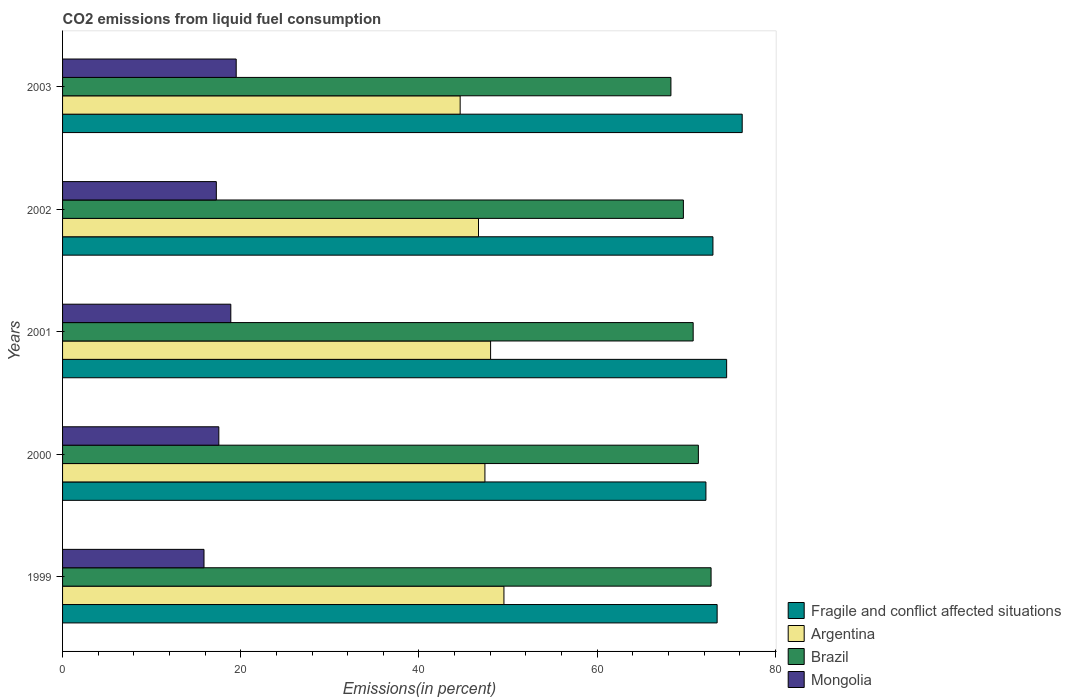How many different coloured bars are there?
Keep it short and to the point. 4. How many groups of bars are there?
Provide a succinct answer. 5. How many bars are there on the 4th tick from the bottom?
Give a very brief answer. 4. What is the label of the 2nd group of bars from the top?
Give a very brief answer. 2002. What is the total CO2 emitted in Fragile and conflict affected situations in 2002?
Keep it short and to the point. 72.99. Across all years, what is the maximum total CO2 emitted in Mongolia?
Your response must be concise. 19.49. Across all years, what is the minimum total CO2 emitted in Mongolia?
Provide a short and direct response. 15.87. What is the total total CO2 emitted in Argentina in the graph?
Your answer should be compact. 236.28. What is the difference between the total CO2 emitted in Argentina in 2000 and that in 2003?
Your response must be concise. 2.78. What is the difference between the total CO2 emitted in Mongolia in 2001 and the total CO2 emitted in Brazil in 1999?
Give a very brief answer. -53.9. What is the average total CO2 emitted in Argentina per year?
Offer a terse response. 47.26. In the year 2000, what is the difference between the total CO2 emitted in Fragile and conflict affected situations and total CO2 emitted in Argentina?
Provide a succinct answer. 24.8. In how many years, is the total CO2 emitted in Argentina greater than 16 %?
Ensure brevity in your answer.  5. What is the ratio of the total CO2 emitted in Brazil in 2000 to that in 2002?
Provide a short and direct response. 1.02. Is the difference between the total CO2 emitted in Fragile and conflict affected situations in 1999 and 2002 greater than the difference between the total CO2 emitted in Argentina in 1999 and 2002?
Offer a terse response. No. What is the difference between the highest and the second highest total CO2 emitted in Mongolia?
Offer a terse response. 0.61. What is the difference between the highest and the lowest total CO2 emitted in Fragile and conflict affected situations?
Give a very brief answer. 4.07. Is the sum of the total CO2 emitted in Fragile and conflict affected situations in 2001 and 2003 greater than the maximum total CO2 emitted in Argentina across all years?
Provide a short and direct response. Yes. Is it the case that in every year, the sum of the total CO2 emitted in Argentina and total CO2 emitted in Fragile and conflict affected situations is greater than the sum of total CO2 emitted in Mongolia and total CO2 emitted in Brazil?
Ensure brevity in your answer.  Yes. How many bars are there?
Make the answer very short. 20. Are the values on the major ticks of X-axis written in scientific E-notation?
Provide a short and direct response. No. How are the legend labels stacked?
Offer a very short reply. Vertical. What is the title of the graph?
Provide a succinct answer. CO2 emissions from liquid fuel consumption. Does "Middle income" appear as one of the legend labels in the graph?
Offer a terse response. No. What is the label or title of the X-axis?
Provide a succinct answer. Emissions(in percent). What is the label or title of the Y-axis?
Ensure brevity in your answer.  Years. What is the Emissions(in percent) in Fragile and conflict affected situations in 1999?
Give a very brief answer. 73.47. What is the Emissions(in percent) in Argentina in 1999?
Your response must be concise. 49.54. What is the Emissions(in percent) of Brazil in 1999?
Provide a short and direct response. 72.78. What is the Emissions(in percent) in Mongolia in 1999?
Ensure brevity in your answer.  15.87. What is the Emissions(in percent) of Fragile and conflict affected situations in 2000?
Give a very brief answer. 72.21. What is the Emissions(in percent) of Argentina in 2000?
Provide a succinct answer. 47.4. What is the Emissions(in percent) of Brazil in 2000?
Offer a terse response. 71.36. What is the Emissions(in percent) of Mongolia in 2000?
Your answer should be very brief. 17.54. What is the Emissions(in percent) in Fragile and conflict affected situations in 2001?
Make the answer very short. 74.53. What is the Emissions(in percent) of Argentina in 2001?
Provide a succinct answer. 48.04. What is the Emissions(in percent) in Brazil in 2001?
Keep it short and to the point. 70.78. What is the Emissions(in percent) of Mongolia in 2001?
Your answer should be compact. 18.88. What is the Emissions(in percent) in Fragile and conflict affected situations in 2002?
Offer a very short reply. 72.99. What is the Emissions(in percent) in Argentina in 2002?
Give a very brief answer. 46.68. What is the Emissions(in percent) in Brazil in 2002?
Make the answer very short. 69.68. What is the Emissions(in percent) in Mongolia in 2002?
Your answer should be compact. 17.26. What is the Emissions(in percent) in Fragile and conflict affected situations in 2003?
Provide a succinct answer. 76.28. What is the Emissions(in percent) in Argentina in 2003?
Provide a succinct answer. 44.62. What is the Emissions(in percent) of Brazil in 2003?
Ensure brevity in your answer.  68.28. What is the Emissions(in percent) in Mongolia in 2003?
Your answer should be compact. 19.49. Across all years, what is the maximum Emissions(in percent) of Fragile and conflict affected situations?
Make the answer very short. 76.28. Across all years, what is the maximum Emissions(in percent) of Argentina?
Your answer should be compact. 49.54. Across all years, what is the maximum Emissions(in percent) of Brazil?
Your response must be concise. 72.78. Across all years, what is the maximum Emissions(in percent) of Mongolia?
Give a very brief answer. 19.49. Across all years, what is the minimum Emissions(in percent) of Fragile and conflict affected situations?
Make the answer very short. 72.21. Across all years, what is the minimum Emissions(in percent) of Argentina?
Make the answer very short. 44.62. Across all years, what is the minimum Emissions(in percent) of Brazil?
Keep it short and to the point. 68.28. Across all years, what is the minimum Emissions(in percent) in Mongolia?
Your answer should be compact. 15.87. What is the total Emissions(in percent) in Fragile and conflict affected situations in the graph?
Your answer should be compact. 369.48. What is the total Emissions(in percent) of Argentina in the graph?
Provide a succinct answer. 236.28. What is the total Emissions(in percent) of Brazil in the graph?
Provide a succinct answer. 352.87. What is the total Emissions(in percent) of Mongolia in the graph?
Provide a short and direct response. 89.04. What is the difference between the Emissions(in percent) in Fragile and conflict affected situations in 1999 and that in 2000?
Provide a succinct answer. 1.26. What is the difference between the Emissions(in percent) in Argentina in 1999 and that in 2000?
Your answer should be compact. 2.13. What is the difference between the Emissions(in percent) in Brazil in 1999 and that in 2000?
Provide a short and direct response. 1.43. What is the difference between the Emissions(in percent) in Mongolia in 1999 and that in 2000?
Give a very brief answer. -1.66. What is the difference between the Emissions(in percent) of Fragile and conflict affected situations in 1999 and that in 2001?
Your response must be concise. -1.06. What is the difference between the Emissions(in percent) of Argentina in 1999 and that in 2001?
Make the answer very short. 1.5. What is the difference between the Emissions(in percent) in Brazil in 1999 and that in 2001?
Offer a very short reply. 2.01. What is the difference between the Emissions(in percent) of Mongolia in 1999 and that in 2001?
Your answer should be very brief. -3.01. What is the difference between the Emissions(in percent) of Fragile and conflict affected situations in 1999 and that in 2002?
Give a very brief answer. 0.47. What is the difference between the Emissions(in percent) in Argentina in 1999 and that in 2002?
Keep it short and to the point. 2.86. What is the difference between the Emissions(in percent) in Brazil in 1999 and that in 2002?
Keep it short and to the point. 3.11. What is the difference between the Emissions(in percent) of Mongolia in 1999 and that in 2002?
Keep it short and to the point. -1.38. What is the difference between the Emissions(in percent) in Fragile and conflict affected situations in 1999 and that in 2003?
Ensure brevity in your answer.  -2.81. What is the difference between the Emissions(in percent) of Argentina in 1999 and that in 2003?
Ensure brevity in your answer.  4.91. What is the difference between the Emissions(in percent) of Brazil in 1999 and that in 2003?
Give a very brief answer. 4.51. What is the difference between the Emissions(in percent) in Mongolia in 1999 and that in 2003?
Give a very brief answer. -3.62. What is the difference between the Emissions(in percent) of Fragile and conflict affected situations in 2000 and that in 2001?
Ensure brevity in your answer.  -2.32. What is the difference between the Emissions(in percent) of Argentina in 2000 and that in 2001?
Provide a short and direct response. -0.64. What is the difference between the Emissions(in percent) in Brazil in 2000 and that in 2001?
Ensure brevity in your answer.  0.58. What is the difference between the Emissions(in percent) in Mongolia in 2000 and that in 2001?
Give a very brief answer. -1.35. What is the difference between the Emissions(in percent) of Fragile and conflict affected situations in 2000 and that in 2002?
Offer a terse response. -0.79. What is the difference between the Emissions(in percent) of Argentina in 2000 and that in 2002?
Give a very brief answer. 0.72. What is the difference between the Emissions(in percent) in Brazil in 2000 and that in 2002?
Ensure brevity in your answer.  1.68. What is the difference between the Emissions(in percent) of Mongolia in 2000 and that in 2002?
Make the answer very short. 0.28. What is the difference between the Emissions(in percent) of Fragile and conflict affected situations in 2000 and that in 2003?
Offer a terse response. -4.07. What is the difference between the Emissions(in percent) in Argentina in 2000 and that in 2003?
Keep it short and to the point. 2.78. What is the difference between the Emissions(in percent) in Brazil in 2000 and that in 2003?
Your answer should be compact. 3.08. What is the difference between the Emissions(in percent) of Mongolia in 2000 and that in 2003?
Provide a succinct answer. -1.95. What is the difference between the Emissions(in percent) in Fragile and conflict affected situations in 2001 and that in 2002?
Offer a very short reply. 1.54. What is the difference between the Emissions(in percent) in Argentina in 2001 and that in 2002?
Your response must be concise. 1.36. What is the difference between the Emissions(in percent) of Brazil in 2001 and that in 2002?
Give a very brief answer. 1.1. What is the difference between the Emissions(in percent) in Mongolia in 2001 and that in 2002?
Offer a terse response. 1.63. What is the difference between the Emissions(in percent) of Fragile and conflict affected situations in 2001 and that in 2003?
Provide a short and direct response. -1.75. What is the difference between the Emissions(in percent) in Argentina in 2001 and that in 2003?
Provide a succinct answer. 3.42. What is the difference between the Emissions(in percent) of Brazil in 2001 and that in 2003?
Make the answer very short. 2.5. What is the difference between the Emissions(in percent) of Mongolia in 2001 and that in 2003?
Keep it short and to the point. -0.61. What is the difference between the Emissions(in percent) in Fragile and conflict affected situations in 2002 and that in 2003?
Offer a terse response. -3.28. What is the difference between the Emissions(in percent) in Argentina in 2002 and that in 2003?
Keep it short and to the point. 2.06. What is the difference between the Emissions(in percent) of Brazil in 2002 and that in 2003?
Offer a very short reply. 1.4. What is the difference between the Emissions(in percent) of Mongolia in 2002 and that in 2003?
Ensure brevity in your answer.  -2.23. What is the difference between the Emissions(in percent) of Fragile and conflict affected situations in 1999 and the Emissions(in percent) of Argentina in 2000?
Make the answer very short. 26.06. What is the difference between the Emissions(in percent) of Fragile and conflict affected situations in 1999 and the Emissions(in percent) of Brazil in 2000?
Offer a very short reply. 2.11. What is the difference between the Emissions(in percent) of Fragile and conflict affected situations in 1999 and the Emissions(in percent) of Mongolia in 2000?
Your answer should be very brief. 55.93. What is the difference between the Emissions(in percent) of Argentina in 1999 and the Emissions(in percent) of Brazil in 2000?
Make the answer very short. -21.82. What is the difference between the Emissions(in percent) in Argentina in 1999 and the Emissions(in percent) in Mongolia in 2000?
Your response must be concise. 32. What is the difference between the Emissions(in percent) of Brazil in 1999 and the Emissions(in percent) of Mongolia in 2000?
Give a very brief answer. 55.25. What is the difference between the Emissions(in percent) of Fragile and conflict affected situations in 1999 and the Emissions(in percent) of Argentina in 2001?
Your response must be concise. 25.43. What is the difference between the Emissions(in percent) of Fragile and conflict affected situations in 1999 and the Emissions(in percent) of Brazil in 2001?
Make the answer very short. 2.69. What is the difference between the Emissions(in percent) of Fragile and conflict affected situations in 1999 and the Emissions(in percent) of Mongolia in 2001?
Provide a short and direct response. 54.58. What is the difference between the Emissions(in percent) of Argentina in 1999 and the Emissions(in percent) of Brazil in 2001?
Provide a short and direct response. -21.24. What is the difference between the Emissions(in percent) of Argentina in 1999 and the Emissions(in percent) of Mongolia in 2001?
Offer a terse response. 30.65. What is the difference between the Emissions(in percent) in Brazil in 1999 and the Emissions(in percent) in Mongolia in 2001?
Provide a short and direct response. 53.9. What is the difference between the Emissions(in percent) in Fragile and conflict affected situations in 1999 and the Emissions(in percent) in Argentina in 2002?
Your answer should be compact. 26.78. What is the difference between the Emissions(in percent) of Fragile and conflict affected situations in 1999 and the Emissions(in percent) of Brazil in 2002?
Your answer should be compact. 3.79. What is the difference between the Emissions(in percent) of Fragile and conflict affected situations in 1999 and the Emissions(in percent) of Mongolia in 2002?
Your answer should be very brief. 56.21. What is the difference between the Emissions(in percent) in Argentina in 1999 and the Emissions(in percent) in Brazil in 2002?
Provide a succinct answer. -20.14. What is the difference between the Emissions(in percent) in Argentina in 1999 and the Emissions(in percent) in Mongolia in 2002?
Offer a very short reply. 32.28. What is the difference between the Emissions(in percent) in Brazil in 1999 and the Emissions(in percent) in Mongolia in 2002?
Keep it short and to the point. 55.53. What is the difference between the Emissions(in percent) in Fragile and conflict affected situations in 1999 and the Emissions(in percent) in Argentina in 2003?
Your answer should be very brief. 28.84. What is the difference between the Emissions(in percent) in Fragile and conflict affected situations in 1999 and the Emissions(in percent) in Brazil in 2003?
Your answer should be very brief. 5.19. What is the difference between the Emissions(in percent) in Fragile and conflict affected situations in 1999 and the Emissions(in percent) in Mongolia in 2003?
Provide a short and direct response. 53.98. What is the difference between the Emissions(in percent) of Argentina in 1999 and the Emissions(in percent) of Brazil in 2003?
Give a very brief answer. -18.74. What is the difference between the Emissions(in percent) in Argentina in 1999 and the Emissions(in percent) in Mongolia in 2003?
Your response must be concise. 30.05. What is the difference between the Emissions(in percent) of Brazil in 1999 and the Emissions(in percent) of Mongolia in 2003?
Make the answer very short. 53.3. What is the difference between the Emissions(in percent) of Fragile and conflict affected situations in 2000 and the Emissions(in percent) of Argentina in 2001?
Offer a very short reply. 24.17. What is the difference between the Emissions(in percent) of Fragile and conflict affected situations in 2000 and the Emissions(in percent) of Brazil in 2001?
Your answer should be very brief. 1.43. What is the difference between the Emissions(in percent) of Fragile and conflict affected situations in 2000 and the Emissions(in percent) of Mongolia in 2001?
Provide a succinct answer. 53.32. What is the difference between the Emissions(in percent) of Argentina in 2000 and the Emissions(in percent) of Brazil in 2001?
Offer a very short reply. -23.37. What is the difference between the Emissions(in percent) in Argentina in 2000 and the Emissions(in percent) in Mongolia in 2001?
Provide a succinct answer. 28.52. What is the difference between the Emissions(in percent) of Brazil in 2000 and the Emissions(in percent) of Mongolia in 2001?
Your answer should be compact. 52.48. What is the difference between the Emissions(in percent) of Fragile and conflict affected situations in 2000 and the Emissions(in percent) of Argentina in 2002?
Your response must be concise. 25.52. What is the difference between the Emissions(in percent) in Fragile and conflict affected situations in 2000 and the Emissions(in percent) in Brazil in 2002?
Offer a terse response. 2.53. What is the difference between the Emissions(in percent) of Fragile and conflict affected situations in 2000 and the Emissions(in percent) of Mongolia in 2002?
Your answer should be very brief. 54.95. What is the difference between the Emissions(in percent) in Argentina in 2000 and the Emissions(in percent) in Brazil in 2002?
Your answer should be very brief. -22.27. What is the difference between the Emissions(in percent) in Argentina in 2000 and the Emissions(in percent) in Mongolia in 2002?
Keep it short and to the point. 30.15. What is the difference between the Emissions(in percent) in Brazil in 2000 and the Emissions(in percent) in Mongolia in 2002?
Keep it short and to the point. 54.1. What is the difference between the Emissions(in percent) of Fragile and conflict affected situations in 2000 and the Emissions(in percent) of Argentina in 2003?
Ensure brevity in your answer.  27.58. What is the difference between the Emissions(in percent) of Fragile and conflict affected situations in 2000 and the Emissions(in percent) of Brazil in 2003?
Your answer should be very brief. 3.93. What is the difference between the Emissions(in percent) of Fragile and conflict affected situations in 2000 and the Emissions(in percent) of Mongolia in 2003?
Your answer should be compact. 52.72. What is the difference between the Emissions(in percent) in Argentina in 2000 and the Emissions(in percent) in Brazil in 2003?
Provide a short and direct response. -20.87. What is the difference between the Emissions(in percent) in Argentina in 2000 and the Emissions(in percent) in Mongolia in 2003?
Your answer should be very brief. 27.91. What is the difference between the Emissions(in percent) of Brazil in 2000 and the Emissions(in percent) of Mongolia in 2003?
Ensure brevity in your answer.  51.87. What is the difference between the Emissions(in percent) in Fragile and conflict affected situations in 2001 and the Emissions(in percent) in Argentina in 2002?
Your answer should be very brief. 27.85. What is the difference between the Emissions(in percent) in Fragile and conflict affected situations in 2001 and the Emissions(in percent) in Brazil in 2002?
Provide a short and direct response. 4.85. What is the difference between the Emissions(in percent) of Fragile and conflict affected situations in 2001 and the Emissions(in percent) of Mongolia in 2002?
Provide a succinct answer. 57.27. What is the difference between the Emissions(in percent) in Argentina in 2001 and the Emissions(in percent) in Brazil in 2002?
Ensure brevity in your answer.  -21.64. What is the difference between the Emissions(in percent) in Argentina in 2001 and the Emissions(in percent) in Mongolia in 2002?
Your answer should be compact. 30.78. What is the difference between the Emissions(in percent) in Brazil in 2001 and the Emissions(in percent) in Mongolia in 2002?
Ensure brevity in your answer.  53.52. What is the difference between the Emissions(in percent) of Fragile and conflict affected situations in 2001 and the Emissions(in percent) of Argentina in 2003?
Ensure brevity in your answer.  29.91. What is the difference between the Emissions(in percent) in Fragile and conflict affected situations in 2001 and the Emissions(in percent) in Brazil in 2003?
Provide a succinct answer. 6.25. What is the difference between the Emissions(in percent) of Fragile and conflict affected situations in 2001 and the Emissions(in percent) of Mongolia in 2003?
Offer a very short reply. 55.04. What is the difference between the Emissions(in percent) in Argentina in 2001 and the Emissions(in percent) in Brazil in 2003?
Keep it short and to the point. -20.24. What is the difference between the Emissions(in percent) in Argentina in 2001 and the Emissions(in percent) in Mongolia in 2003?
Provide a succinct answer. 28.55. What is the difference between the Emissions(in percent) in Brazil in 2001 and the Emissions(in percent) in Mongolia in 2003?
Give a very brief answer. 51.29. What is the difference between the Emissions(in percent) of Fragile and conflict affected situations in 2002 and the Emissions(in percent) of Argentina in 2003?
Make the answer very short. 28.37. What is the difference between the Emissions(in percent) in Fragile and conflict affected situations in 2002 and the Emissions(in percent) in Brazil in 2003?
Give a very brief answer. 4.72. What is the difference between the Emissions(in percent) in Fragile and conflict affected situations in 2002 and the Emissions(in percent) in Mongolia in 2003?
Give a very brief answer. 53.51. What is the difference between the Emissions(in percent) of Argentina in 2002 and the Emissions(in percent) of Brazil in 2003?
Provide a succinct answer. -21.6. What is the difference between the Emissions(in percent) in Argentina in 2002 and the Emissions(in percent) in Mongolia in 2003?
Make the answer very short. 27.19. What is the difference between the Emissions(in percent) of Brazil in 2002 and the Emissions(in percent) of Mongolia in 2003?
Offer a terse response. 50.19. What is the average Emissions(in percent) in Fragile and conflict affected situations per year?
Offer a terse response. 73.9. What is the average Emissions(in percent) of Argentina per year?
Keep it short and to the point. 47.26. What is the average Emissions(in percent) of Brazil per year?
Offer a very short reply. 70.57. What is the average Emissions(in percent) of Mongolia per year?
Ensure brevity in your answer.  17.81. In the year 1999, what is the difference between the Emissions(in percent) of Fragile and conflict affected situations and Emissions(in percent) of Argentina?
Your response must be concise. 23.93. In the year 1999, what is the difference between the Emissions(in percent) in Fragile and conflict affected situations and Emissions(in percent) in Brazil?
Give a very brief answer. 0.68. In the year 1999, what is the difference between the Emissions(in percent) of Fragile and conflict affected situations and Emissions(in percent) of Mongolia?
Ensure brevity in your answer.  57.59. In the year 1999, what is the difference between the Emissions(in percent) of Argentina and Emissions(in percent) of Brazil?
Provide a short and direct response. -23.25. In the year 1999, what is the difference between the Emissions(in percent) in Argentina and Emissions(in percent) in Mongolia?
Provide a succinct answer. 33.66. In the year 1999, what is the difference between the Emissions(in percent) in Brazil and Emissions(in percent) in Mongolia?
Make the answer very short. 56.91. In the year 2000, what is the difference between the Emissions(in percent) of Fragile and conflict affected situations and Emissions(in percent) of Argentina?
Offer a very short reply. 24.8. In the year 2000, what is the difference between the Emissions(in percent) in Fragile and conflict affected situations and Emissions(in percent) in Brazil?
Keep it short and to the point. 0.85. In the year 2000, what is the difference between the Emissions(in percent) of Fragile and conflict affected situations and Emissions(in percent) of Mongolia?
Your answer should be compact. 54.67. In the year 2000, what is the difference between the Emissions(in percent) of Argentina and Emissions(in percent) of Brazil?
Ensure brevity in your answer.  -23.96. In the year 2000, what is the difference between the Emissions(in percent) of Argentina and Emissions(in percent) of Mongolia?
Ensure brevity in your answer.  29.87. In the year 2000, what is the difference between the Emissions(in percent) in Brazil and Emissions(in percent) in Mongolia?
Provide a succinct answer. 53.82. In the year 2001, what is the difference between the Emissions(in percent) in Fragile and conflict affected situations and Emissions(in percent) in Argentina?
Your response must be concise. 26.49. In the year 2001, what is the difference between the Emissions(in percent) of Fragile and conflict affected situations and Emissions(in percent) of Brazil?
Give a very brief answer. 3.76. In the year 2001, what is the difference between the Emissions(in percent) of Fragile and conflict affected situations and Emissions(in percent) of Mongolia?
Provide a short and direct response. 55.65. In the year 2001, what is the difference between the Emissions(in percent) in Argentina and Emissions(in percent) in Brazil?
Your response must be concise. -22.74. In the year 2001, what is the difference between the Emissions(in percent) in Argentina and Emissions(in percent) in Mongolia?
Your response must be concise. 29.15. In the year 2001, what is the difference between the Emissions(in percent) of Brazil and Emissions(in percent) of Mongolia?
Offer a terse response. 51.89. In the year 2002, what is the difference between the Emissions(in percent) in Fragile and conflict affected situations and Emissions(in percent) in Argentina?
Keep it short and to the point. 26.31. In the year 2002, what is the difference between the Emissions(in percent) of Fragile and conflict affected situations and Emissions(in percent) of Brazil?
Provide a succinct answer. 3.32. In the year 2002, what is the difference between the Emissions(in percent) in Fragile and conflict affected situations and Emissions(in percent) in Mongolia?
Provide a short and direct response. 55.74. In the year 2002, what is the difference between the Emissions(in percent) in Argentina and Emissions(in percent) in Brazil?
Your response must be concise. -23. In the year 2002, what is the difference between the Emissions(in percent) in Argentina and Emissions(in percent) in Mongolia?
Give a very brief answer. 29.42. In the year 2002, what is the difference between the Emissions(in percent) of Brazil and Emissions(in percent) of Mongolia?
Your response must be concise. 52.42. In the year 2003, what is the difference between the Emissions(in percent) in Fragile and conflict affected situations and Emissions(in percent) in Argentina?
Provide a short and direct response. 31.65. In the year 2003, what is the difference between the Emissions(in percent) of Fragile and conflict affected situations and Emissions(in percent) of Brazil?
Offer a very short reply. 8. In the year 2003, what is the difference between the Emissions(in percent) of Fragile and conflict affected situations and Emissions(in percent) of Mongolia?
Provide a short and direct response. 56.79. In the year 2003, what is the difference between the Emissions(in percent) in Argentina and Emissions(in percent) in Brazil?
Your answer should be compact. -23.65. In the year 2003, what is the difference between the Emissions(in percent) of Argentina and Emissions(in percent) of Mongolia?
Provide a short and direct response. 25.13. In the year 2003, what is the difference between the Emissions(in percent) of Brazil and Emissions(in percent) of Mongolia?
Offer a terse response. 48.79. What is the ratio of the Emissions(in percent) of Fragile and conflict affected situations in 1999 to that in 2000?
Offer a very short reply. 1.02. What is the ratio of the Emissions(in percent) of Argentina in 1999 to that in 2000?
Make the answer very short. 1.04. What is the ratio of the Emissions(in percent) in Mongolia in 1999 to that in 2000?
Give a very brief answer. 0.91. What is the ratio of the Emissions(in percent) in Fragile and conflict affected situations in 1999 to that in 2001?
Give a very brief answer. 0.99. What is the ratio of the Emissions(in percent) of Argentina in 1999 to that in 2001?
Keep it short and to the point. 1.03. What is the ratio of the Emissions(in percent) of Brazil in 1999 to that in 2001?
Offer a very short reply. 1.03. What is the ratio of the Emissions(in percent) in Mongolia in 1999 to that in 2001?
Offer a very short reply. 0.84. What is the ratio of the Emissions(in percent) in Fragile and conflict affected situations in 1999 to that in 2002?
Keep it short and to the point. 1.01. What is the ratio of the Emissions(in percent) in Argentina in 1999 to that in 2002?
Keep it short and to the point. 1.06. What is the ratio of the Emissions(in percent) in Brazil in 1999 to that in 2002?
Provide a short and direct response. 1.04. What is the ratio of the Emissions(in percent) of Mongolia in 1999 to that in 2002?
Your answer should be very brief. 0.92. What is the ratio of the Emissions(in percent) of Fragile and conflict affected situations in 1999 to that in 2003?
Your answer should be compact. 0.96. What is the ratio of the Emissions(in percent) in Argentina in 1999 to that in 2003?
Ensure brevity in your answer.  1.11. What is the ratio of the Emissions(in percent) of Brazil in 1999 to that in 2003?
Offer a very short reply. 1.07. What is the ratio of the Emissions(in percent) in Mongolia in 1999 to that in 2003?
Your answer should be compact. 0.81. What is the ratio of the Emissions(in percent) in Fragile and conflict affected situations in 2000 to that in 2001?
Give a very brief answer. 0.97. What is the ratio of the Emissions(in percent) of Argentina in 2000 to that in 2001?
Ensure brevity in your answer.  0.99. What is the ratio of the Emissions(in percent) of Brazil in 2000 to that in 2001?
Provide a short and direct response. 1.01. What is the ratio of the Emissions(in percent) of Mongolia in 2000 to that in 2001?
Ensure brevity in your answer.  0.93. What is the ratio of the Emissions(in percent) of Argentina in 2000 to that in 2002?
Make the answer very short. 1.02. What is the ratio of the Emissions(in percent) of Brazil in 2000 to that in 2002?
Keep it short and to the point. 1.02. What is the ratio of the Emissions(in percent) in Mongolia in 2000 to that in 2002?
Provide a succinct answer. 1.02. What is the ratio of the Emissions(in percent) of Fragile and conflict affected situations in 2000 to that in 2003?
Give a very brief answer. 0.95. What is the ratio of the Emissions(in percent) in Argentina in 2000 to that in 2003?
Keep it short and to the point. 1.06. What is the ratio of the Emissions(in percent) in Brazil in 2000 to that in 2003?
Your answer should be very brief. 1.05. What is the ratio of the Emissions(in percent) of Mongolia in 2000 to that in 2003?
Provide a succinct answer. 0.9. What is the ratio of the Emissions(in percent) in Fragile and conflict affected situations in 2001 to that in 2002?
Offer a very short reply. 1.02. What is the ratio of the Emissions(in percent) in Argentina in 2001 to that in 2002?
Ensure brevity in your answer.  1.03. What is the ratio of the Emissions(in percent) in Brazil in 2001 to that in 2002?
Keep it short and to the point. 1.02. What is the ratio of the Emissions(in percent) of Mongolia in 2001 to that in 2002?
Your response must be concise. 1.09. What is the ratio of the Emissions(in percent) in Fragile and conflict affected situations in 2001 to that in 2003?
Make the answer very short. 0.98. What is the ratio of the Emissions(in percent) in Argentina in 2001 to that in 2003?
Provide a succinct answer. 1.08. What is the ratio of the Emissions(in percent) in Brazil in 2001 to that in 2003?
Provide a short and direct response. 1.04. What is the ratio of the Emissions(in percent) of Fragile and conflict affected situations in 2002 to that in 2003?
Your response must be concise. 0.96. What is the ratio of the Emissions(in percent) in Argentina in 2002 to that in 2003?
Your answer should be very brief. 1.05. What is the ratio of the Emissions(in percent) of Brazil in 2002 to that in 2003?
Ensure brevity in your answer.  1.02. What is the ratio of the Emissions(in percent) of Mongolia in 2002 to that in 2003?
Give a very brief answer. 0.89. What is the difference between the highest and the second highest Emissions(in percent) of Fragile and conflict affected situations?
Provide a short and direct response. 1.75. What is the difference between the highest and the second highest Emissions(in percent) in Argentina?
Ensure brevity in your answer.  1.5. What is the difference between the highest and the second highest Emissions(in percent) in Brazil?
Give a very brief answer. 1.43. What is the difference between the highest and the second highest Emissions(in percent) of Mongolia?
Give a very brief answer. 0.61. What is the difference between the highest and the lowest Emissions(in percent) in Fragile and conflict affected situations?
Make the answer very short. 4.07. What is the difference between the highest and the lowest Emissions(in percent) of Argentina?
Keep it short and to the point. 4.91. What is the difference between the highest and the lowest Emissions(in percent) of Brazil?
Keep it short and to the point. 4.51. What is the difference between the highest and the lowest Emissions(in percent) in Mongolia?
Your response must be concise. 3.62. 